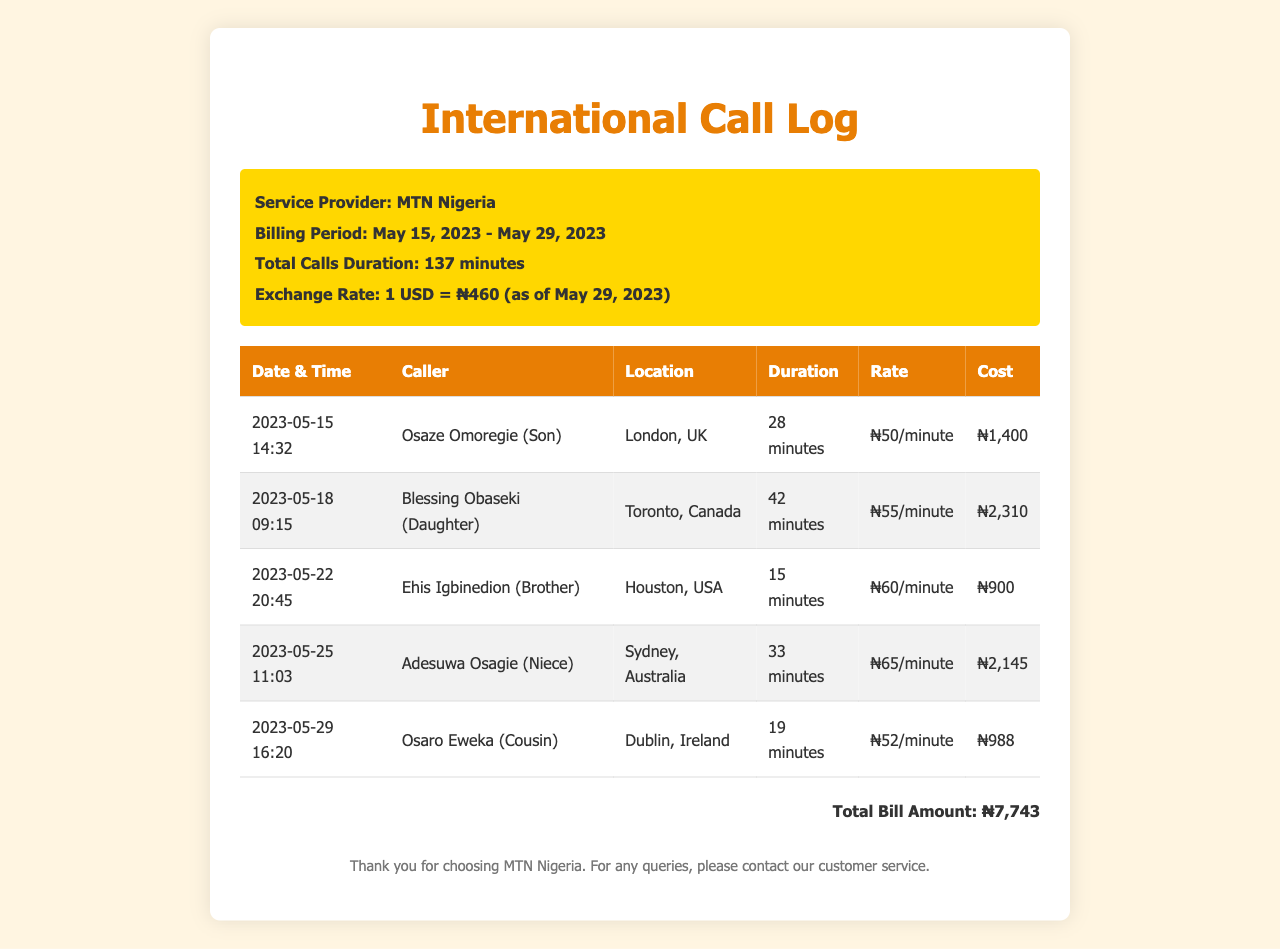What is the service provider? The document states that the service provider is MTN Nigeria.
Answer: MTN Nigeria What is the total call duration? The total call duration is mentioned in the document as 137 minutes.
Answer: 137 minutes Who called from Toronto? According to the document, Blessing Obaseki (Daughter) is the caller from Toronto.
Answer: Blessing Obaseki (Daughter) What was the rate per minute for the call to Houston? The rate for the call to Houston is listed as ₦60/minute in the document.
Answer: ₦60/minute What is the total bill amount? The total bill amount is provided at the end of the document, calculated from all the calls.
Answer: ₦7,743 How long was the call to Dublin? The duration of the call to Dublin is specified as 19 minutes.
Answer: 19 minutes Which family member had the longest call? The longest call was made to Blessing Obaseki (Daughter) for 42 minutes.
Answer: Blessing Obaseki (Daughter) What is the exchange rate mentioned? The document specifies the exchange rate as 1 USD = ₦460.
Answer: 1 USD = ₦460 What was the cost of the call to Sydney? The cost of the call to Sydney is given as ₦2,145 in the document.
Answer: ₦2,145 